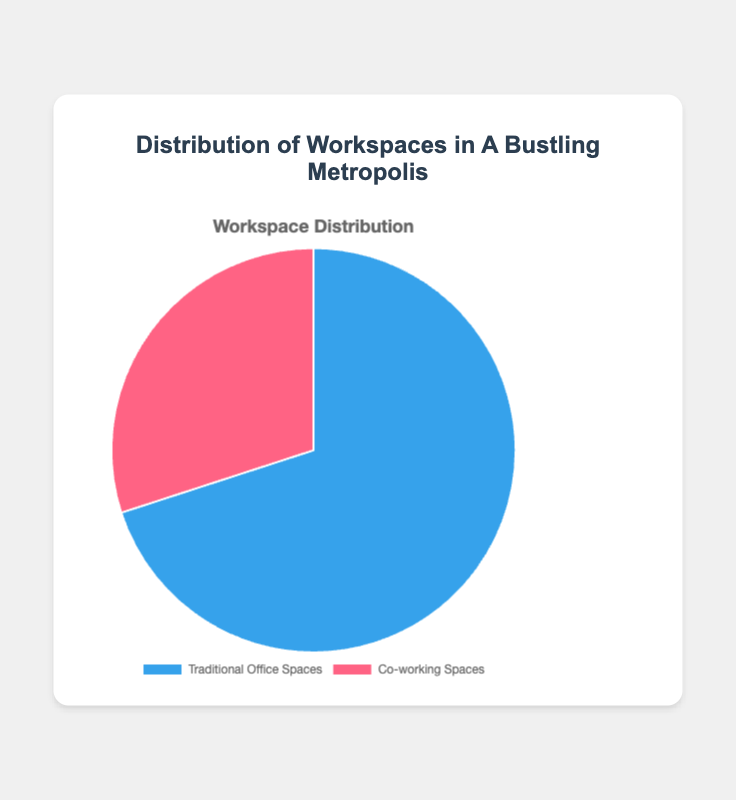Which type of workspace has a larger share in the metropolis? By looking at the chart, the section representing Traditional Office Spaces is larger than the section for Co-working Spaces.
Answer: Traditional Office Spaces What is the percentage share of Co-working Spaces in the metropolis? Refer to the data points on the chart; 30% represents Co-working Spaces. Since the total must add up to 100%, this section is 30%.
Answer: 30% What is the difference in percentage between Traditional Office Spaces and Co-working Spaces? Subtract the percentage of Co-working Spaces from Traditional Office Spaces: 70% - 30% = 40%.
Answer: 40% What fraction of the total workspaces do Traditional Office Spaces represent? Traditional Office Spaces account for 70%, which is equivalent to 70/100 or 7/10.
Answer: 7/10 If 10 new workspaces were to be added to represent an equal distribution of Traditional Office Spaces and Co-working Spaces, how many would each type have? Currently, there are 7 Traditional and 3 Co-working Spaces out of 10. To make it equal, we need to add x workspaces to each until they are equal: 7 + x = 3 + x + 4. Thus, each would then have five.
Answer: 5 and 5 How much more space does the section for Traditional Office Spaces take compared to Co-working Spaces visually? The blue section for Traditional Office Spaces occupies a significantly larger area than the pink section for Co-working Spaces, approximately more than double in size.
Answer: Twice as large If we combine both types of workspaces, what is the total percentage? Sum up the individual percentages: 70% for Traditional Office Spaces and 30% for Co-working Spaces: 70% + 30% = 100%.
Answer: 100% If the entire pie represents 1,000 workspaces, how many of these are Co-working Spaces? Co-working Spaces constitute 30% of the total. Calculating 30% of 1,000 gives 1,000 * 0.30 = 300.
Answer: 300 Based on the chart, which workspace type is visually represented by the color blue? By correlating the color coding with the chart labels, Traditional Office Spaces are illustrated in blue.
Answer: Traditional Office Spaces 